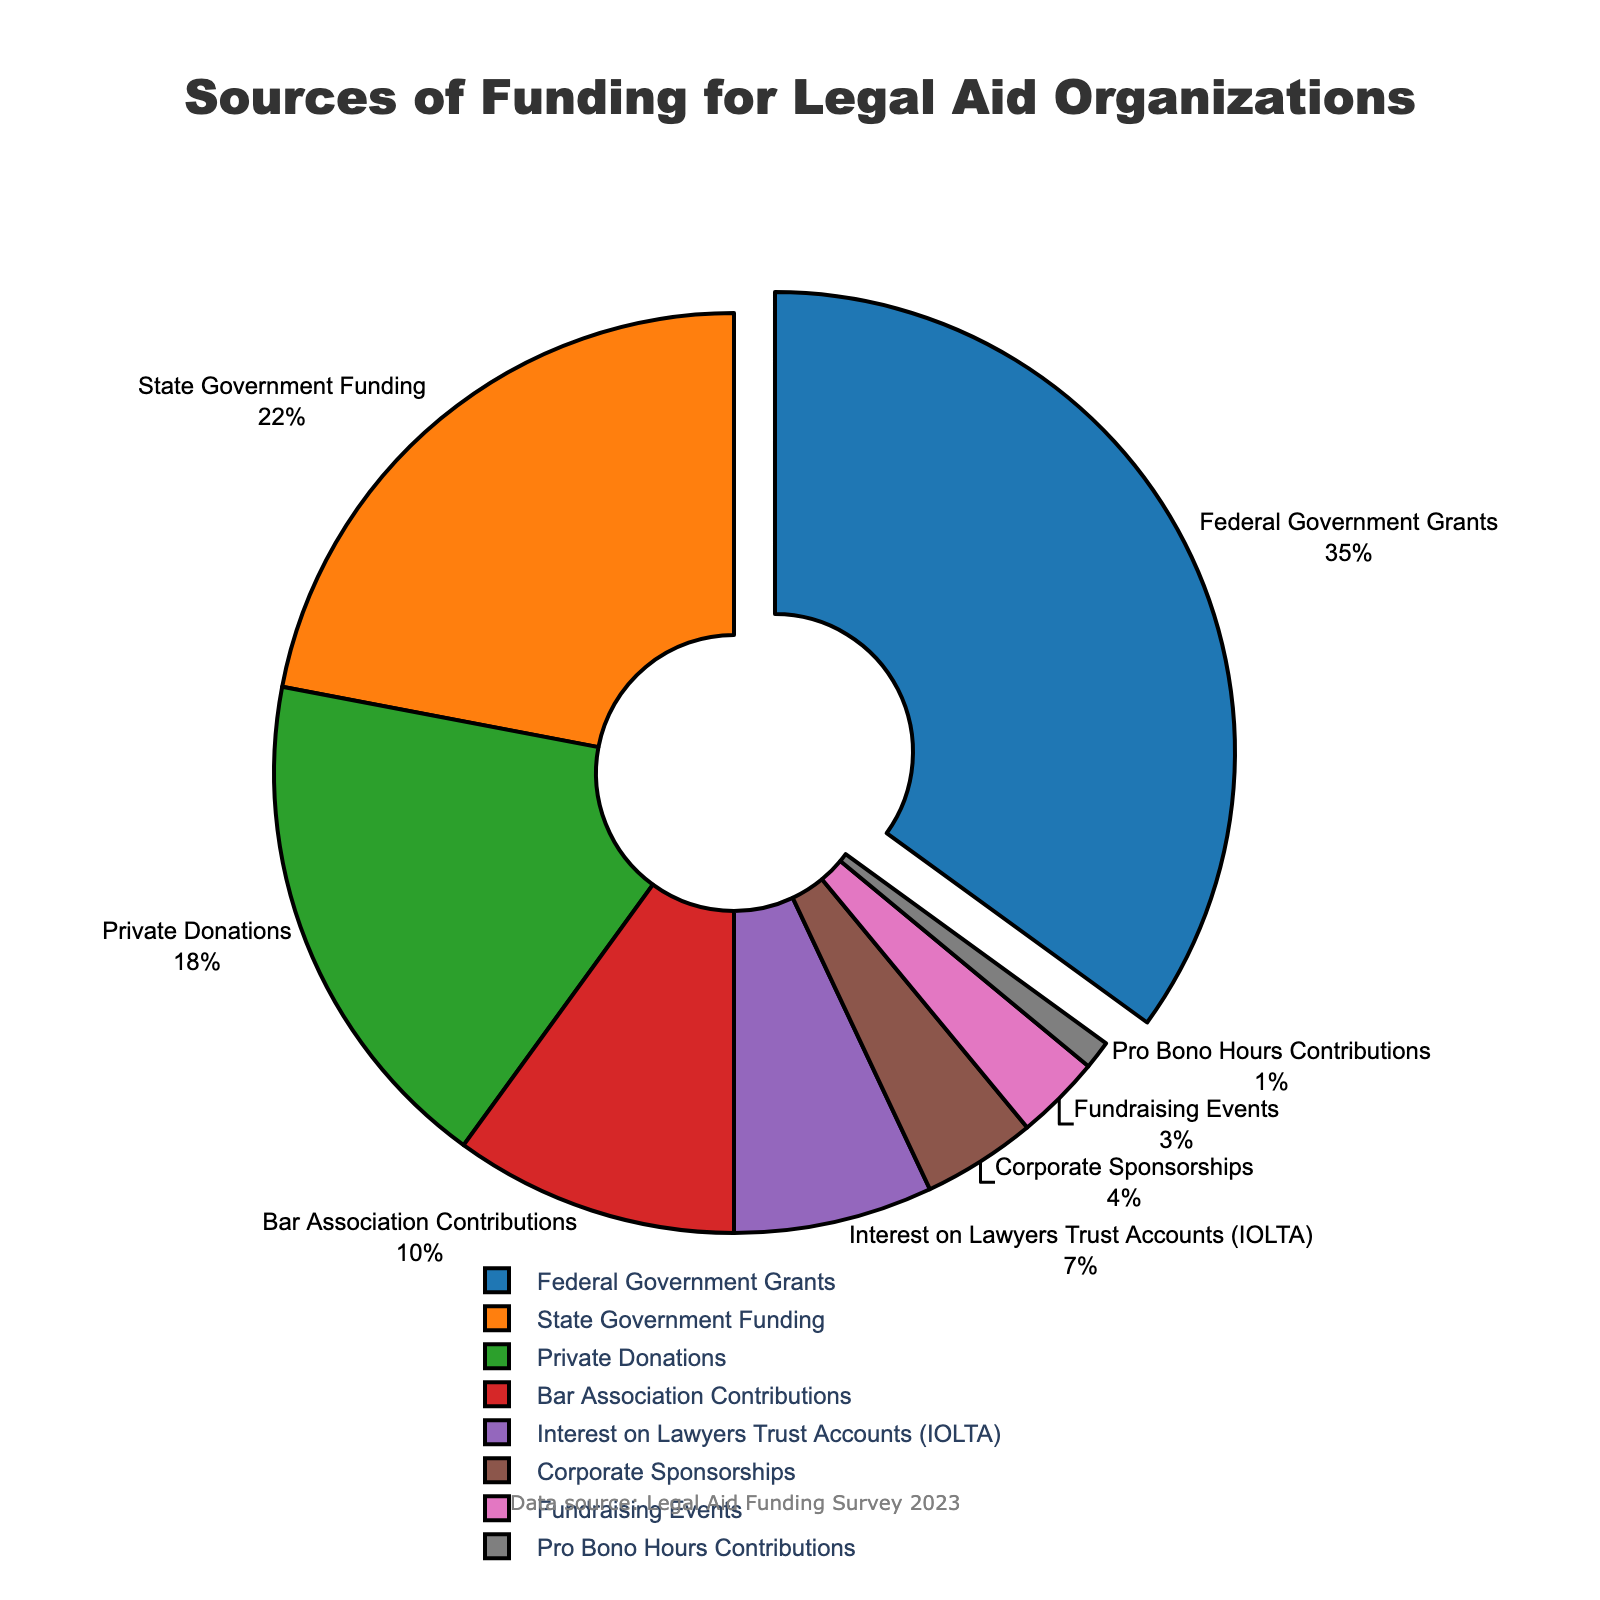Which funding source contributes the most to legal aid organizations? The funding source with the highest percentage is the 'Federal Government Grants' at 35%.
Answer: Federal Government Grants What is the combined percentage of funding from Interest on Lawyers Trust Accounts (IOLTA) and Corporate Sponsorships? The percentage for IOLTA is 7% and for Corporate Sponsorships is 4%. Adding these together, 7 + 4 = 11%.
Answer: 11% Which funding source contributes less, Private Donations or Bar Association Contributions? Private Donations are at 18%, whereas Bar Association Contributions are at 10%. Therefore, Bar Association Contributions contribute less.
Answer: Bar Association Contributions By how much does State Government Funding exceed the combined contributions of Fundraising Events and Pro Bono Hours Contributions? State Government Funding is at 22%. Fundraising Events contribute 3% and Pro Bono Hours Contributions are at 1%, making their combined total 3 + 1 = 4%. Therefore, 22 - 4 = 18%.
Answer: 18% What is the difference in funding between the Federal Government Grants and Private Donations? Federal Government Grants are at 35%, and Private Donations are at 18%. Therefore, the difference is 35 - 18 = 17%.
Answer: 17% What percentage of the total funding comes from Government sources (Federal and State combined)? Federal Government Grants are at 35% and State Government Funding is at 22%. Adding them together, 35 + 22 = 57%.
Answer: 57% Which funding source is represented in red? The code section provided does not explicitly state the specific colors for each source, but asking visually about color representation should refer back to the pie chart.
Answer: Not Answerable from the data/code provided Which funding sources have a lower contribution than the Bar Association Contributions? Bar Association Contributions are at 10%. The sources with lower contributions are Interest on Lawyers Trust Accounts (IOLTA) at 7%, Corporate Sponsorships at 4%, Fundraising Events at 3%, and Pro Bono Hours Contributions at 1%.
Answer: IOLTA, Corporate Sponsorships, Fundraising Events, Pro Bono Hours Contributions What is the total percentage of smaller funding sources (less than 10%) combined? The smaller sources are IOLTA (7%), Corporate Sponsorships (4%), Fundraising Events (3%), and Pro Bono Hours Contributions (1%). Combining these gives 7 + 4 + 3 + 1 = 15%.
Answer: 15% Is the contribution from Private Donations more than twice the contribution from Corporate Sponsorships? Private Donations contribute 18% while Corporate Sponsorships contribute 4%. Twice the contribution from Corporate Sponsorships is 4 * 2 = 8%. Since 18% is greater than 8%, Private Donations contribute more than twice the amount.
Answer: Yes 